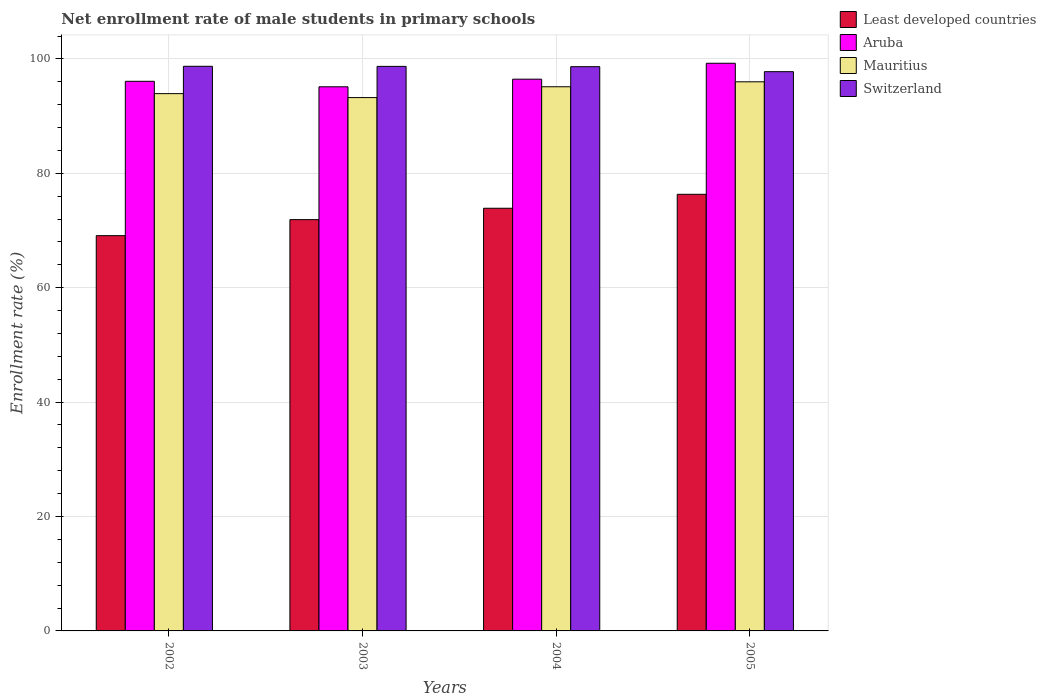How many groups of bars are there?
Ensure brevity in your answer.  4. Are the number of bars per tick equal to the number of legend labels?
Your response must be concise. Yes. How many bars are there on the 1st tick from the left?
Provide a succinct answer. 4. How many bars are there on the 2nd tick from the right?
Make the answer very short. 4. In how many cases, is the number of bars for a given year not equal to the number of legend labels?
Your answer should be compact. 0. What is the net enrollment rate of male students in primary schools in Mauritius in 2004?
Offer a terse response. 95.13. Across all years, what is the maximum net enrollment rate of male students in primary schools in Mauritius?
Your answer should be compact. 96. Across all years, what is the minimum net enrollment rate of male students in primary schools in Switzerland?
Your answer should be very brief. 97.77. In which year was the net enrollment rate of male students in primary schools in Least developed countries minimum?
Your answer should be very brief. 2002. What is the total net enrollment rate of male students in primary schools in Least developed countries in the graph?
Make the answer very short. 291.22. What is the difference between the net enrollment rate of male students in primary schools in Least developed countries in 2004 and that in 2005?
Ensure brevity in your answer.  -2.44. What is the difference between the net enrollment rate of male students in primary schools in Switzerland in 2002 and the net enrollment rate of male students in primary schools in Least developed countries in 2004?
Provide a short and direct response. 24.82. What is the average net enrollment rate of male students in primary schools in Least developed countries per year?
Offer a terse response. 72.81. In the year 2003, what is the difference between the net enrollment rate of male students in primary schools in Switzerland and net enrollment rate of male students in primary schools in Aruba?
Offer a very short reply. 3.57. In how many years, is the net enrollment rate of male students in primary schools in Least developed countries greater than 96 %?
Provide a short and direct response. 0. What is the ratio of the net enrollment rate of male students in primary schools in Mauritius in 2002 to that in 2004?
Ensure brevity in your answer.  0.99. What is the difference between the highest and the second highest net enrollment rate of male students in primary schools in Mauritius?
Provide a short and direct response. 0.87. What is the difference between the highest and the lowest net enrollment rate of male students in primary schools in Switzerland?
Offer a terse response. 0.94. What does the 1st bar from the left in 2004 represents?
Offer a terse response. Least developed countries. What does the 2nd bar from the right in 2005 represents?
Provide a short and direct response. Mauritius. How many bars are there?
Keep it short and to the point. 16. Are all the bars in the graph horizontal?
Your response must be concise. No. What is the difference between two consecutive major ticks on the Y-axis?
Offer a very short reply. 20. Does the graph contain any zero values?
Your response must be concise. No. Where does the legend appear in the graph?
Provide a succinct answer. Top right. What is the title of the graph?
Keep it short and to the point. Net enrollment rate of male students in primary schools. What is the label or title of the Y-axis?
Keep it short and to the point. Enrollment rate (%). What is the Enrollment rate (%) in Least developed countries in 2002?
Provide a short and direct response. 69.1. What is the Enrollment rate (%) in Aruba in 2002?
Offer a terse response. 96.08. What is the Enrollment rate (%) of Mauritius in 2002?
Offer a terse response. 93.93. What is the Enrollment rate (%) of Switzerland in 2002?
Your answer should be very brief. 98.71. What is the Enrollment rate (%) in Least developed countries in 2003?
Make the answer very short. 71.9. What is the Enrollment rate (%) in Aruba in 2003?
Keep it short and to the point. 95.13. What is the Enrollment rate (%) in Mauritius in 2003?
Give a very brief answer. 93.24. What is the Enrollment rate (%) of Switzerland in 2003?
Your answer should be very brief. 98.69. What is the Enrollment rate (%) of Least developed countries in 2004?
Offer a very short reply. 73.89. What is the Enrollment rate (%) in Aruba in 2004?
Offer a very short reply. 96.46. What is the Enrollment rate (%) of Mauritius in 2004?
Your answer should be very brief. 95.13. What is the Enrollment rate (%) in Switzerland in 2004?
Offer a terse response. 98.64. What is the Enrollment rate (%) of Least developed countries in 2005?
Offer a very short reply. 76.33. What is the Enrollment rate (%) in Aruba in 2005?
Offer a very short reply. 99.24. What is the Enrollment rate (%) in Mauritius in 2005?
Offer a terse response. 96. What is the Enrollment rate (%) in Switzerland in 2005?
Provide a succinct answer. 97.77. Across all years, what is the maximum Enrollment rate (%) in Least developed countries?
Ensure brevity in your answer.  76.33. Across all years, what is the maximum Enrollment rate (%) in Aruba?
Offer a terse response. 99.24. Across all years, what is the maximum Enrollment rate (%) in Mauritius?
Ensure brevity in your answer.  96. Across all years, what is the maximum Enrollment rate (%) in Switzerland?
Your answer should be very brief. 98.71. Across all years, what is the minimum Enrollment rate (%) in Least developed countries?
Your response must be concise. 69.1. Across all years, what is the minimum Enrollment rate (%) in Aruba?
Offer a very short reply. 95.13. Across all years, what is the minimum Enrollment rate (%) of Mauritius?
Your answer should be compact. 93.24. Across all years, what is the minimum Enrollment rate (%) in Switzerland?
Provide a succinct answer. 97.77. What is the total Enrollment rate (%) in Least developed countries in the graph?
Give a very brief answer. 291.22. What is the total Enrollment rate (%) of Aruba in the graph?
Give a very brief answer. 386.91. What is the total Enrollment rate (%) in Mauritius in the graph?
Give a very brief answer. 378.3. What is the total Enrollment rate (%) in Switzerland in the graph?
Your answer should be very brief. 393.81. What is the difference between the Enrollment rate (%) in Least developed countries in 2002 and that in 2003?
Offer a very short reply. -2.8. What is the difference between the Enrollment rate (%) of Aruba in 2002 and that in 2003?
Ensure brevity in your answer.  0.96. What is the difference between the Enrollment rate (%) in Mauritius in 2002 and that in 2003?
Your response must be concise. 0.69. What is the difference between the Enrollment rate (%) in Switzerland in 2002 and that in 2003?
Your answer should be compact. 0.02. What is the difference between the Enrollment rate (%) of Least developed countries in 2002 and that in 2004?
Your answer should be compact. -4.79. What is the difference between the Enrollment rate (%) of Aruba in 2002 and that in 2004?
Your answer should be very brief. -0.38. What is the difference between the Enrollment rate (%) in Mauritius in 2002 and that in 2004?
Your response must be concise. -1.2. What is the difference between the Enrollment rate (%) in Switzerland in 2002 and that in 2004?
Make the answer very short. 0.07. What is the difference between the Enrollment rate (%) in Least developed countries in 2002 and that in 2005?
Your response must be concise. -7.23. What is the difference between the Enrollment rate (%) in Aruba in 2002 and that in 2005?
Give a very brief answer. -3.16. What is the difference between the Enrollment rate (%) of Mauritius in 2002 and that in 2005?
Provide a succinct answer. -2.07. What is the difference between the Enrollment rate (%) of Switzerland in 2002 and that in 2005?
Your response must be concise. 0.94. What is the difference between the Enrollment rate (%) of Least developed countries in 2003 and that in 2004?
Offer a terse response. -1.99. What is the difference between the Enrollment rate (%) of Aruba in 2003 and that in 2004?
Your response must be concise. -1.34. What is the difference between the Enrollment rate (%) in Mauritius in 2003 and that in 2004?
Make the answer very short. -1.89. What is the difference between the Enrollment rate (%) of Switzerland in 2003 and that in 2004?
Provide a short and direct response. 0.05. What is the difference between the Enrollment rate (%) in Least developed countries in 2003 and that in 2005?
Your response must be concise. -4.43. What is the difference between the Enrollment rate (%) of Aruba in 2003 and that in 2005?
Your response must be concise. -4.12. What is the difference between the Enrollment rate (%) in Mauritius in 2003 and that in 2005?
Offer a very short reply. -2.76. What is the difference between the Enrollment rate (%) of Switzerland in 2003 and that in 2005?
Provide a succinct answer. 0.92. What is the difference between the Enrollment rate (%) in Least developed countries in 2004 and that in 2005?
Ensure brevity in your answer.  -2.44. What is the difference between the Enrollment rate (%) of Aruba in 2004 and that in 2005?
Give a very brief answer. -2.78. What is the difference between the Enrollment rate (%) in Mauritius in 2004 and that in 2005?
Keep it short and to the point. -0.87. What is the difference between the Enrollment rate (%) of Switzerland in 2004 and that in 2005?
Give a very brief answer. 0.87. What is the difference between the Enrollment rate (%) in Least developed countries in 2002 and the Enrollment rate (%) in Aruba in 2003?
Give a very brief answer. -26.03. What is the difference between the Enrollment rate (%) in Least developed countries in 2002 and the Enrollment rate (%) in Mauritius in 2003?
Provide a short and direct response. -24.14. What is the difference between the Enrollment rate (%) of Least developed countries in 2002 and the Enrollment rate (%) of Switzerland in 2003?
Your answer should be very brief. -29.6. What is the difference between the Enrollment rate (%) in Aruba in 2002 and the Enrollment rate (%) in Mauritius in 2003?
Provide a short and direct response. 2.85. What is the difference between the Enrollment rate (%) of Aruba in 2002 and the Enrollment rate (%) of Switzerland in 2003?
Offer a very short reply. -2.61. What is the difference between the Enrollment rate (%) in Mauritius in 2002 and the Enrollment rate (%) in Switzerland in 2003?
Your response must be concise. -4.76. What is the difference between the Enrollment rate (%) in Least developed countries in 2002 and the Enrollment rate (%) in Aruba in 2004?
Your response must be concise. -27.36. What is the difference between the Enrollment rate (%) in Least developed countries in 2002 and the Enrollment rate (%) in Mauritius in 2004?
Your answer should be very brief. -26.03. What is the difference between the Enrollment rate (%) of Least developed countries in 2002 and the Enrollment rate (%) of Switzerland in 2004?
Your answer should be very brief. -29.54. What is the difference between the Enrollment rate (%) of Aruba in 2002 and the Enrollment rate (%) of Mauritius in 2004?
Provide a succinct answer. 0.95. What is the difference between the Enrollment rate (%) of Aruba in 2002 and the Enrollment rate (%) of Switzerland in 2004?
Give a very brief answer. -2.56. What is the difference between the Enrollment rate (%) of Mauritius in 2002 and the Enrollment rate (%) of Switzerland in 2004?
Provide a succinct answer. -4.71. What is the difference between the Enrollment rate (%) in Least developed countries in 2002 and the Enrollment rate (%) in Aruba in 2005?
Make the answer very short. -30.14. What is the difference between the Enrollment rate (%) of Least developed countries in 2002 and the Enrollment rate (%) of Mauritius in 2005?
Ensure brevity in your answer.  -26.9. What is the difference between the Enrollment rate (%) in Least developed countries in 2002 and the Enrollment rate (%) in Switzerland in 2005?
Make the answer very short. -28.67. What is the difference between the Enrollment rate (%) in Aruba in 2002 and the Enrollment rate (%) in Mauritius in 2005?
Your answer should be compact. 0.09. What is the difference between the Enrollment rate (%) of Aruba in 2002 and the Enrollment rate (%) of Switzerland in 2005?
Ensure brevity in your answer.  -1.69. What is the difference between the Enrollment rate (%) in Mauritius in 2002 and the Enrollment rate (%) in Switzerland in 2005?
Your answer should be very brief. -3.84. What is the difference between the Enrollment rate (%) of Least developed countries in 2003 and the Enrollment rate (%) of Aruba in 2004?
Your answer should be very brief. -24.56. What is the difference between the Enrollment rate (%) in Least developed countries in 2003 and the Enrollment rate (%) in Mauritius in 2004?
Ensure brevity in your answer.  -23.23. What is the difference between the Enrollment rate (%) in Least developed countries in 2003 and the Enrollment rate (%) in Switzerland in 2004?
Provide a short and direct response. -26.74. What is the difference between the Enrollment rate (%) of Aruba in 2003 and the Enrollment rate (%) of Mauritius in 2004?
Your response must be concise. -0.01. What is the difference between the Enrollment rate (%) in Aruba in 2003 and the Enrollment rate (%) in Switzerland in 2004?
Give a very brief answer. -3.52. What is the difference between the Enrollment rate (%) of Mauritius in 2003 and the Enrollment rate (%) of Switzerland in 2004?
Provide a succinct answer. -5.4. What is the difference between the Enrollment rate (%) in Least developed countries in 2003 and the Enrollment rate (%) in Aruba in 2005?
Your answer should be compact. -27.34. What is the difference between the Enrollment rate (%) in Least developed countries in 2003 and the Enrollment rate (%) in Mauritius in 2005?
Offer a very short reply. -24.1. What is the difference between the Enrollment rate (%) of Least developed countries in 2003 and the Enrollment rate (%) of Switzerland in 2005?
Give a very brief answer. -25.87. What is the difference between the Enrollment rate (%) in Aruba in 2003 and the Enrollment rate (%) in Mauritius in 2005?
Offer a terse response. -0.87. What is the difference between the Enrollment rate (%) of Aruba in 2003 and the Enrollment rate (%) of Switzerland in 2005?
Make the answer very short. -2.64. What is the difference between the Enrollment rate (%) in Mauritius in 2003 and the Enrollment rate (%) in Switzerland in 2005?
Provide a succinct answer. -4.53. What is the difference between the Enrollment rate (%) of Least developed countries in 2004 and the Enrollment rate (%) of Aruba in 2005?
Your answer should be compact. -25.35. What is the difference between the Enrollment rate (%) in Least developed countries in 2004 and the Enrollment rate (%) in Mauritius in 2005?
Ensure brevity in your answer.  -22.11. What is the difference between the Enrollment rate (%) in Least developed countries in 2004 and the Enrollment rate (%) in Switzerland in 2005?
Ensure brevity in your answer.  -23.88. What is the difference between the Enrollment rate (%) of Aruba in 2004 and the Enrollment rate (%) of Mauritius in 2005?
Your response must be concise. 0.46. What is the difference between the Enrollment rate (%) in Aruba in 2004 and the Enrollment rate (%) in Switzerland in 2005?
Give a very brief answer. -1.31. What is the difference between the Enrollment rate (%) in Mauritius in 2004 and the Enrollment rate (%) in Switzerland in 2005?
Provide a short and direct response. -2.64. What is the average Enrollment rate (%) in Least developed countries per year?
Your answer should be very brief. 72.81. What is the average Enrollment rate (%) in Aruba per year?
Give a very brief answer. 96.73. What is the average Enrollment rate (%) of Mauritius per year?
Keep it short and to the point. 94.57. What is the average Enrollment rate (%) in Switzerland per year?
Give a very brief answer. 98.45. In the year 2002, what is the difference between the Enrollment rate (%) in Least developed countries and Enrollment rate (%) in Aruba?
Give a very brief answer. -26.99. In the year 2002, what is the difference between the Enrollment rate (%) in Least developed countries and Enrollment rate (%) in Mauritius?
Ensure brevity in your answer.  -24.83. In the year 2002, what is the difference between the Enrollment rate (%) in Least developed countries and Enrollment rate (%) in Switzerland?
Offer a terse response. -29.61. In the year 2002, what is the difference between the Enrollment rate (%) of Aruba and Enrollment rate (%) of Mauritius?
Make the answer very short. 2.15. In the year 2002, what is the difference between the Enrollment rate (%) in Aruba and Enrollment rate (%) in Switzerland?
Keep it short and to the point. -2.63. In the year 2002, what is the difference between the Enrollment rate (%) in Mauritius and Enrollment rate (%) in Switzerland?
Offer a terse response. -4.78. In the year 2003, what is the difference between the Enrollment rate (%) of Least developed countries and Enrollment rate (%) of Aruba?
Provide a short and direct response. -23.22. In the year 2003, what is the difference between the Enrollment rate (%) of Least developed countries and Enrollment rate (%) of Mauritius?
Provide a succinct answer. -21.34. In the year 2003, what is the difference between the Enrollment rate (%) of Least developed countries and Enrollment rate (%) of Switzerland?
Give a very brief answer. -26.79. In the year 2003, what is the difference between the Enrollment rate (%) of Aruba and Enrollment rate (%) of Mauritius?
Provide a short and direct response. 1.89. In the year 2003, what is the difference between the Enrollment rate (%) in Aruba and Enrollment rate (%) in Switzerland?
Your response must be concise. -3.57. In the year 2003, what is the difference between the Enrollment rate (%) in Mauritius and Enrollment rate (%) in Switzerland?
Provide a succinct answer. -5.46. In the year 2004, what is the difference between the Enrollment rate (%) in Least developed countries and Enrollment rate (%) in Aruba?
Offer a very short reply. -22.57. In the year 2004, what is the difference between the Enrollment rate (%) in Least developed countries and Enrollment rate (%) in Mauritius?
Provide a succinct answer. -21.24. In the year 2004, what is the difference between the Enrollment rate (%) of Least developed countries and Enrollment rate (%) of Switzerland?
Ensure brevity in your answer.  -24.75. In the year 2004, what is the difference between the Enrollment rate (%) in Aruba and Enrollment rate (%) in Mauritius?
Keep it short and to the point. 1.33. In the year 2004, what is the difference between the Enrollment rate (%) in Aruba and Enrollment rate (%) in Switzerland?
Provide a succinct answer. -2.18. In the year 2004, what is the difference between the Enrollment rate (%) of Mauritius and Enrollment rate (%) of Switzerland?
Keep it short and to the point. -3.51. In the year 2005, what is the difference between the Enrollment rate (%) in Least developed countries and Enrollment rate (%) in Aruba?
Give a very brief answer. -22.91. In the year 2005, what is the difference between the Enrollment rate (%) of Least developed countries and Enrollment rate (%) of Mauritius?
Make the answer very short. -19.67. In the year 2005, what is the difference between the Enrollment rate (%) of Least developed countries and Enrollment rate (%) of Switzerland?
Offer a terse response. -21.44. In the year 2005, what is the difference between the Enrollment rate (%) of Aruba and Enrollment rate (%) of Mauritius?
Your answer should be very brief. 3.24. In the year 2005, what is the difference between the Enrollment rate (%) of Aruba and Enrollment rate (%) of Switzerland?
Offer a very short reply. 1.47. In the year 2005, what is the difference between the Enrollment rate (%) in Mauritius and Enrollment rate (%) in Switzerland?
Make the answer very short. -1.77. What is the ratio of the Enrollment rate (%) in Least developed countries in 2002 to that in 2003?
Offer a very short reply. 0.96. What is the ratio of the Enrollment rate (%) of Aruba in 2002 to that in 2003?
Keep it short and to the point. 1.01. What is the ratio of the Enrollment rate (%) in Mauritius in 2002 to that in 2003?
Your response must be concise. 1.01. What is the ratio of the Enrollment rate (%) in Switzerland in 2002 to that in 2003?
Provide a succinct answer. 1. What is the ratio of the Enrollment rate (%) of Least developed countries in 2002 to that in 2004?
Offer a very short reply. 0.94. What is the ratio of the Enrollment rate (%) in Aruba in 2002 to that in 2004?
Keep it short and to the point. 1. What is the ratio of the Enrollment rate (%) of Mauritius in 2002 to that in 2004?
Keep it short and to the point. 0.99. What is the ratio of the Enrollment rate (%) of Least developed countries in 2002 to that in 2005?
Give a very brief answer. 0.91. What is the ratio of the Enrollment rate (%) of Aruba in 2002 to that in 2005?
Your answer should be very brief. 0.97. What is the ratio of the Enrollment rate (%) in Mauritius in 2002 to that in 2005?
Your answer should be very brief. 0.98. What is the ratio of the Enrollment rate (%) in Switzerland in 2002 to that in 2005?
Offer a very short reply. 1.01. What is the ratio of the Enrollment rate (%) of Least developed countries in 2003 to that in 2004?
Keep it short and to the point. 0.97. What is the ratio of the Enrollment rate (%) in Aruba in 2003 to that in 2004?
Your answer should be very brief. 0.99. What is the ratio of the Enrollment rate (%) in Mauritius in 2003 to that in 2004?
Provide a succinct answer. 0.98. What is the ratio of the Enrollment rate (%) in Least developed countries in 2003 to that in 2005?
Offer a very short reply. 0.94. What is the ratio of the Enrollment rate (%) in Aruba in 2003 to that in 2005?
Your answer should be compact. 0.96. What is the ratio of the Enrollment rate (%) of Mauritius in 2003 to that in 2005?
Your response must be concise. 0.97. What is the ratio of the Enrollment rate (%) in Switzerland in 2003 to that in 2005?
Provide a short and direct response. 1.01. What is the ratio of the Enrollment rate (%) of Least developed countries in 2004 to that in 2005?
Your answer should be compact. 0.97. What is the ratio of the Enrollment rate (%) in Aruba in 2004 to that in 2005?
Your answer should be compact. 0.97. What is the ratio of the Enrollment rate (%) in Mauritius in 2004 to that in 2005?
Make the answer very short. 0.99. What is the ratio of the Enrollment rate (%) in Switzerland in 2004 to that in 2005?
Offer a very short reply. 1.01. What is the difference between the highest and the second highest Enrollment rate (%) of Least developed countries?
Keep it short and to the point. 2.44. What is the difference between the highest and the second highest Enrollment rate (%) in Aruba?
Your response must be concise. 2.78. What is the difference between the highest and the second highest Enrollment rate (%) of Mauritius?
Offer a very short reply. 0.87. What is the difference between the highest and the second highest Enrollment rate (%) in Switzerland?
Offer a very short reply. 0.02. What is the difference between the highest and the lowest Enrollment rate (%) of Least developed countries?
Provide a short and direct response. 7.23. What is the difference between the highest and the lowest Enrollment rate (%) of Aruba?
Your response must be concise. 4.12. What is the difference between the highest and the lowest Enrollment rate (%) of Mauritius?
Make the answer very short. 2.76. What is the difference between the highest and the lowest Enrollment rate (%) in Switzerland?
Keep it short and to the point. 0.94. 